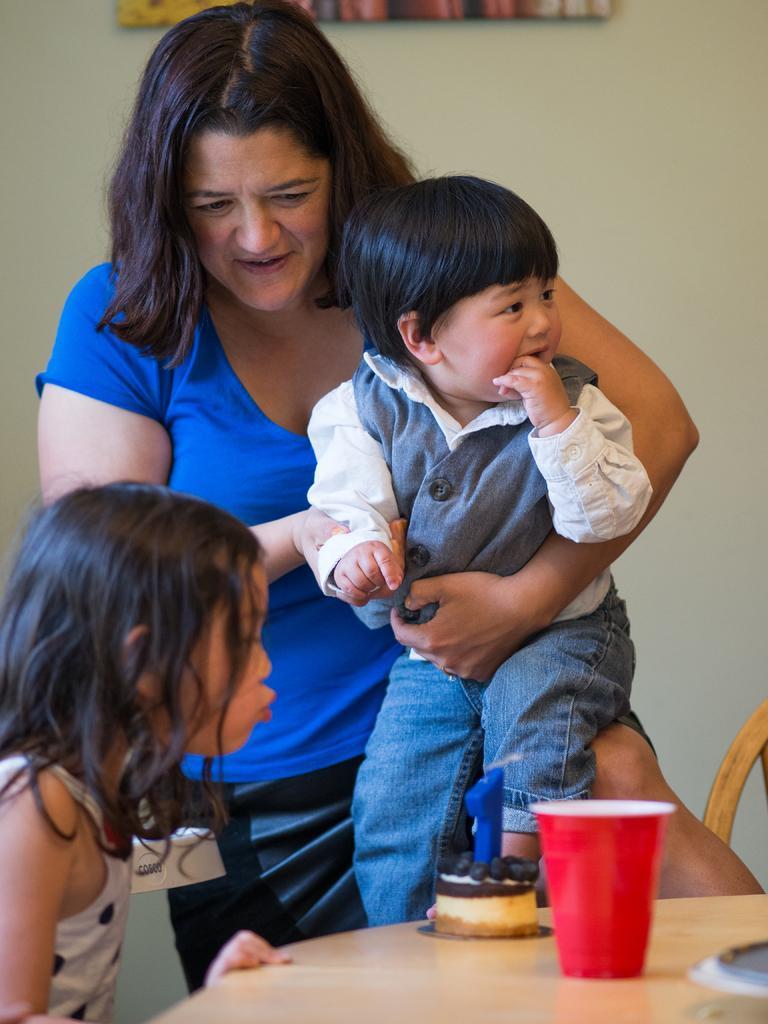Could you give a brief overview of what you see in this image? In this image I see a woman who is holding a child and I can see a girl over here and I can also see there is a cake and a cup on the table. In the background I can see the wall. 